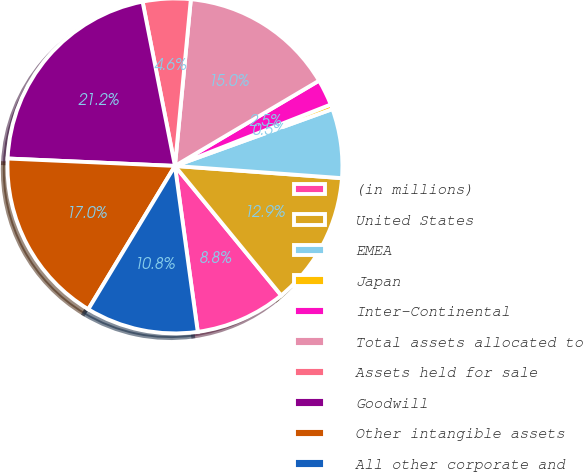Convert chart. <chart><loc_0><loc_0><loc_500><loc_500><pie_chart><fcel>(in millions)<fcel>United States<fcel>EMEA<fcel>Japan<fcel>Inter-Continental<fcel>Total assets allocated to<fcel>Assets held for sale<fcel>Goodwill<fcel>Other intangible assets<fcel>All other corporate and<nl><fcel>8.76%<fcel>12.9%<fcel>6.68%<fcel>0.46%<fcel>2.53%<fcel>14.98%<fcel>4.61%<fcel>21.2%<fcel>17.05%<fcel>10.83%<nl></chart> 